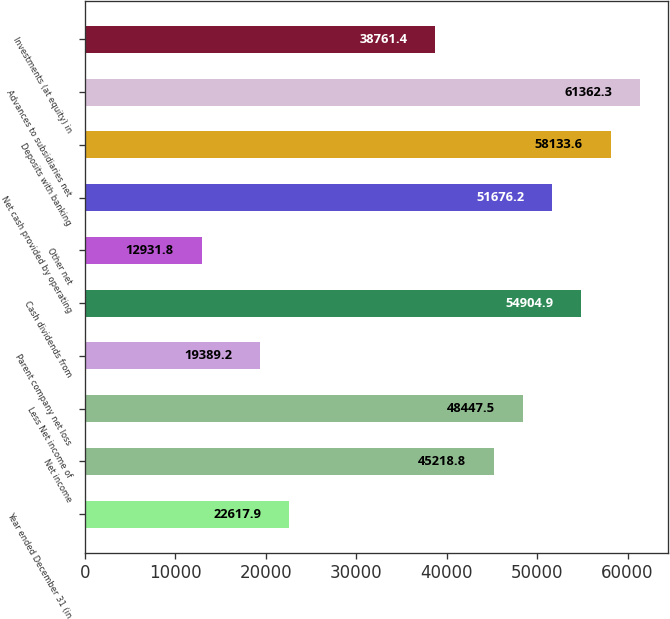Convert chart to OTSL. <chart><loc_0><loc_0><loc_500><loc_500><bar_chart><fcel>Year ended December 31 (in<fcel>Net income<fcel>Less Net income of<fcel>Parent company net loss<fcel>Cash dividends from<fcel>Other net<fcel>Net cash provided by operating<fcel>Deposits with banking<fcel>Advances to subsidiaries net<fcel>Investments (at equity) in<nl><fcel>22617.9<fcel>45218.8<fcel>48447.5<fcel>19389.2<fcel>54904.9<fcel>12931.8<fcel>51676.2<fcel>58133.6<fcel>61362.3<fcel>38761.4<nl></chart> 